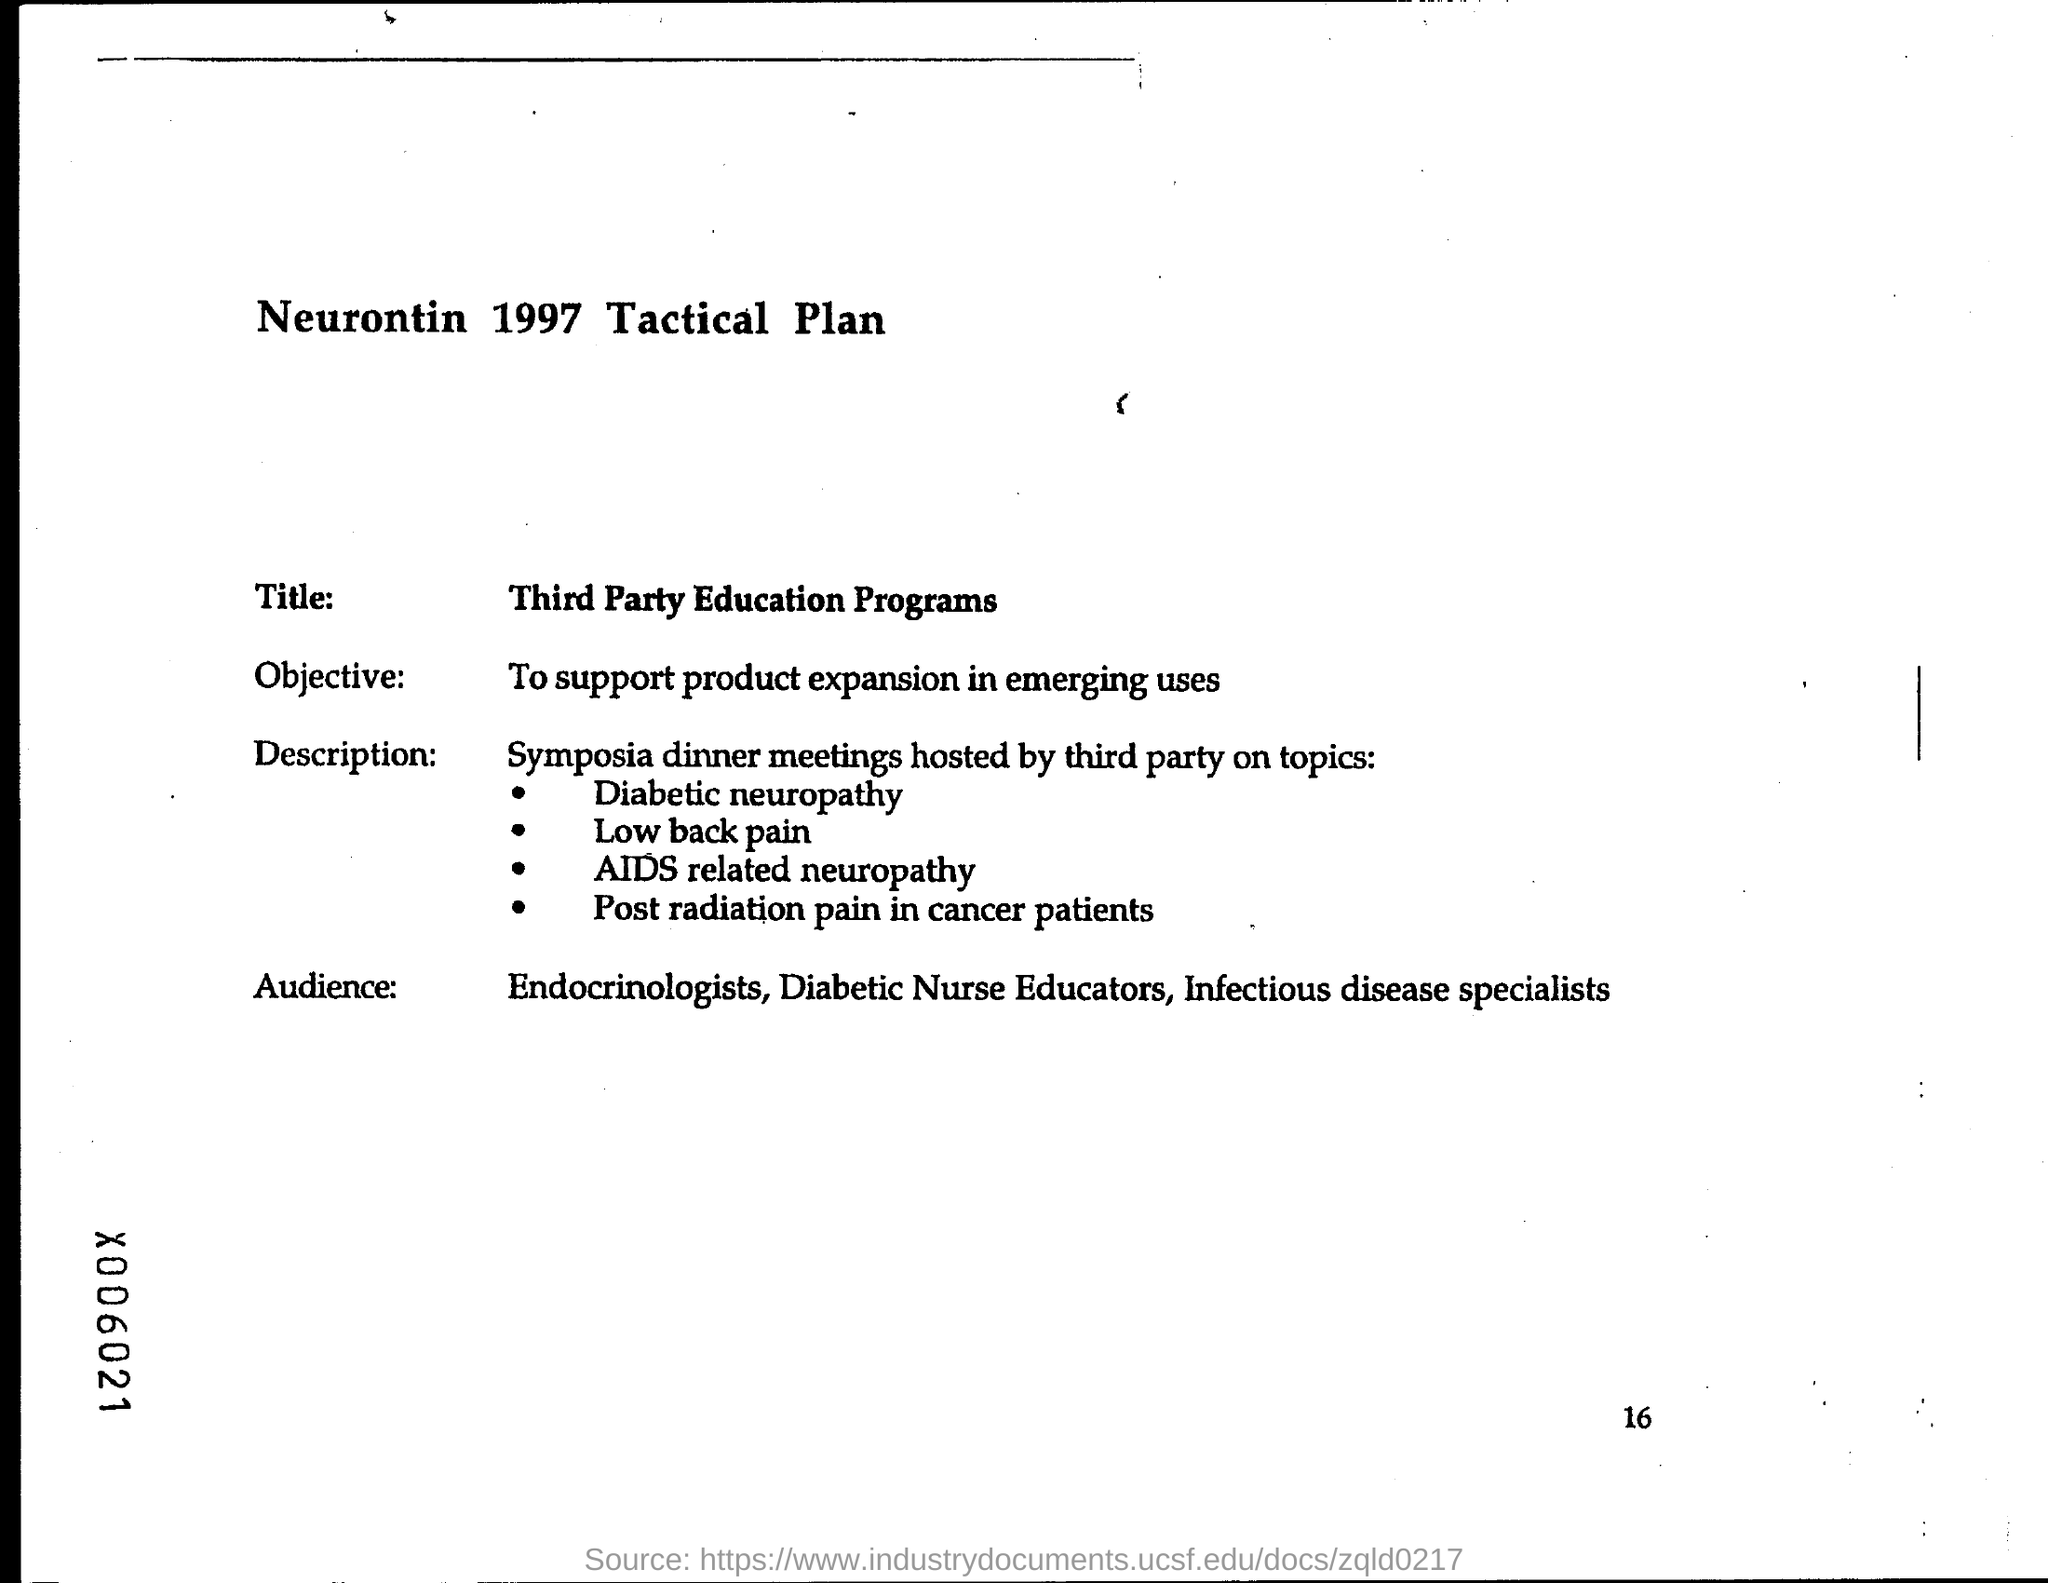What is the objective of the programs?
Ensure brevity in your answer.  To support product expansion in emerging uses. 